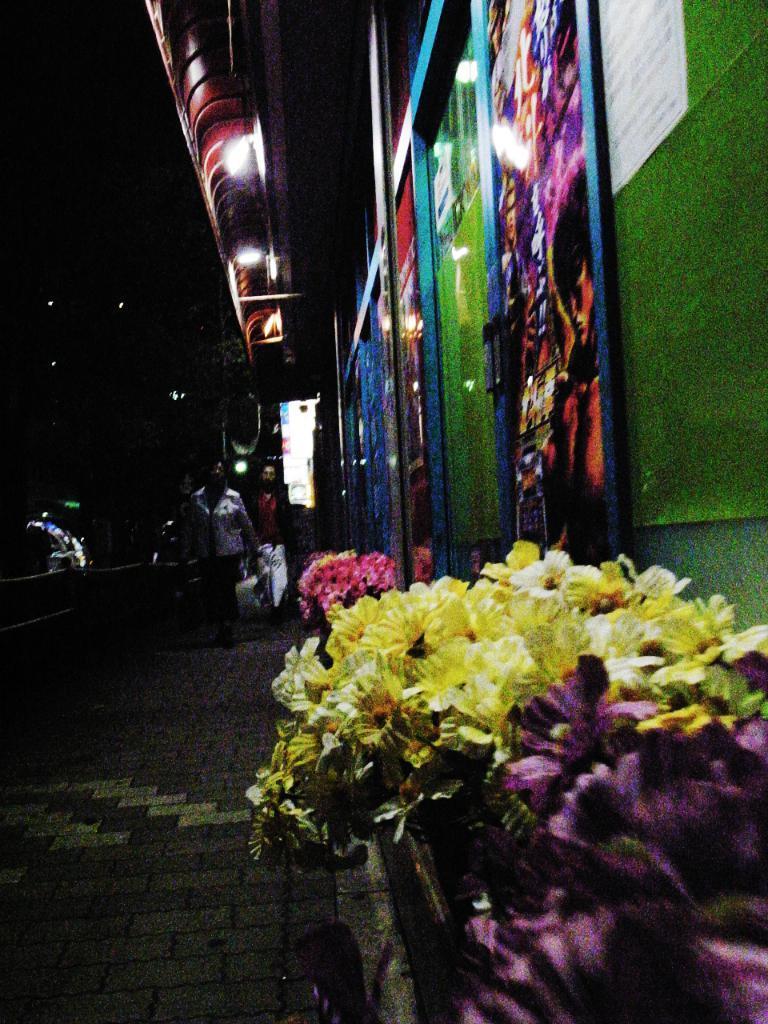How would you summarize this image in a sentence or two? In this image, on the right corner, we can see a plant with flowers which are in violet and yellow color. On the right side, we can see some photo frames which are attached to a wall. In the middle of the image, we can see two men. In the background, we can see black color. 